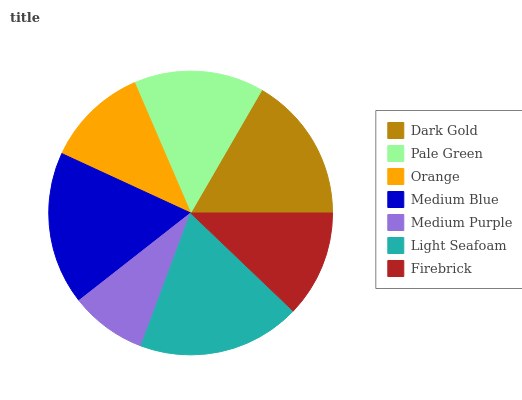Is Medium Purple the minimum?
Answer yes or no. Yes. Is Light Seafoam the maximum?
Answer yes or no. Yes. Is Pale Green the minimum?
Answer yes or no. No. Is Pale Green the maximum?
Answer yes or no. No. Is Dark Gold greater than Pale Green?
Answer yes or no. Yes. Is Pale Green less than Dark Gold?
Answer yes or no. Yes. Is Pale Green greater than Dark Gold?
Answer yes or no. No. Is Dark Gold less than Pale Green?
Answer yes or no. No. Is Pale Green the high median?
Answer yes or no. Yes. Is Pale Green the low median?
Answer yes or no. Yes. Is Orange the high median?
Answer yes or no. No. Is Orange the low median?
Answer yes or no. No. 